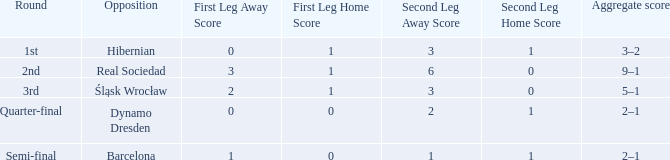What was the first leg score against Real Sociedad? 3–1 (a). 